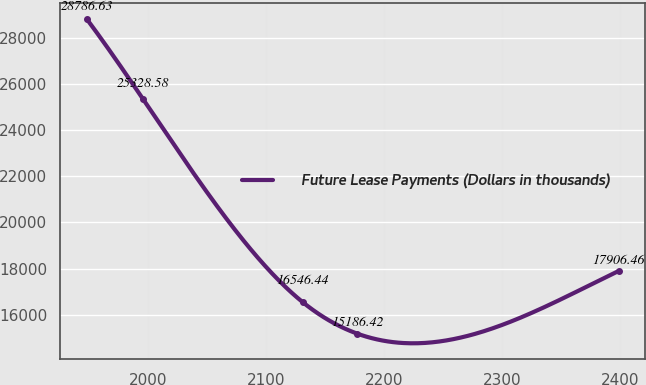Convert chart to OTSL. <chart><loc_0><loc_0><loc_500><loc_500><line_chart><ecel><fcel>Future Lease Payments (Dollars in thousands)<nl><fcel>1948.59<fcel>28786.6<nl><fcel>1996.09<fcel>25328.6<nl><fcel>2131.27<fcel>16546.4<nl><fcel>2177.46<fcel>15186.4<nl><fcel>2398.81<fcel>17906.5<nl></chart> 